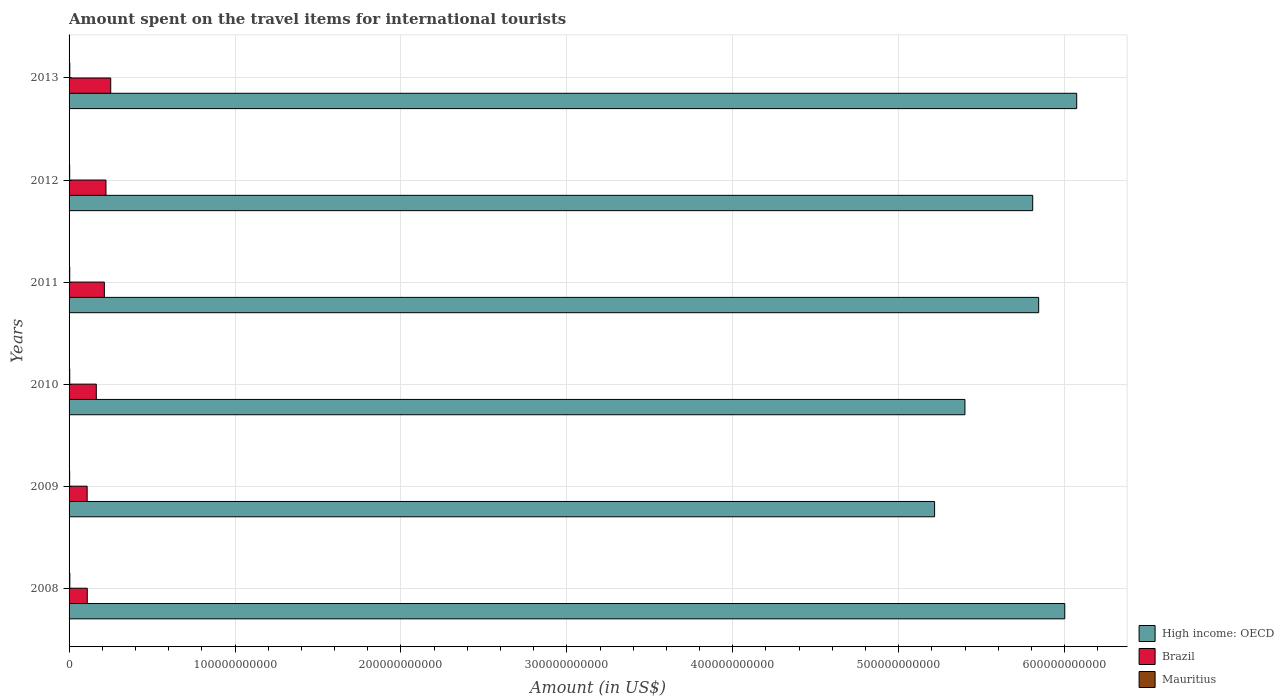How many different coloured bars are there?
Make the answer very short. 3. Are the number of bars on each tick of the Y-axis equal?
Make the answer very short. Yes. What is the amount spent on the travel items for international tourists in Brazil in 2010?
Provide a succinct answer. 1.64e+1. Across all years, what is the maximum amount spent on the travel items for international tourists in Mauritius?
Provide a short and direct response. 4.52e+08. Across all years, what is the minimum amount spent on the travel items for international tourists in High income: OECD?
Offer a terse response. 5.22e+11. What is the total amount spent on the travel items for international tourists in Mauritius in the graph?
Provide a short and direct response. 2.41e+09. What is the difference between the amount spent on the travel items for international tourists in High income: OECD in 2009 and that in 2010?
Provide a short and direct response. -1.83e+1. What is the difference between the amount spent on the travel items for international tourists in Brazil in 2009 and the amount spent on the travel items for international tourists in Mauritius in 2011?
Offer a very short reply. 1.05e+1. What is the average amount spent on the travel items for international tourists in High income: OECD per year?
Your answer should be compact. 5.72e+11. In the year 2012, what is the difference between the amount spent on the travel items for international tourists in Brazil and amount spent on the travel items for international tourists in Mauritius?
Your answer should be compact. 2.19e+1. What is the ratio of the amount spent on the travel items for international tourists in Brazil in 2012 to that in 2013?
Ensure brevity in your answer.  0.89. What is the difference between the highest and the second highest amount spent on the travel items for international tourists in Mauritius?
Your response must be concise. 1.60e+07. What is the difference between the highest and the lowest amount spent on the travel items for international tourists in Brazil?
Your answer should be very brief. 1.42e+1. In how many years, is the amount spent on the travel items for international tourists in Brazil greater than the average amount spent on the travel items for international tourists in Brazil taken over all years?
Provide a short and direct response. 3. Is the sum of the amount spent on the travel items for international tourists in High income: OECD in 2012 and 2013 greater than the maximum amount spent on the travel items for international tourists in Mauritius across all years?
Make the answer very short. Yes. What does the 3rd bar from the top in 2011 represents?
Your answer should be very brief. High income: OECD. What does the 2nd bar from the bottom in 2013 represents?
Your response must be concise. Brazil. Is it the case that in every year, the sum of the amount spent on the travel items for international tourists in High income: OECD and amount spent on the travel items for international tourists in Brazil is greater than the amount spent on the travel items for international tourists in Mauritius?
Keep it short and to the point. Yes. How many years are there in the graph?
Your answer should be compact. 6. What is the difference between two consecutive major ticks on the X-axis?
Provide a short and direct response. 1.00e+11. What is the title of the graph?
Your answer should be very brief. Amount spent on the travel items for international tourists. Does "Samoa" appear as one of the legend labels in the graph?
Provide a short and direct response. No. What is the label or title of the X-axis?
Provide a short and direct response. Amount (in US$). What is the label or title of the Y-axis?
Ensure brevity in your answer.  Years. What is the Amount (in US$) in High income: OECD in 2008?
Your response must be concise. 6.00e+11. What is the Amount (in US$) of Brazil in 2008?
Offer a very short reply. 1.10e+1. What is the Amount (in US$) of Mauritius in 2008?
Your answer should be very brief. 4.52e+08. What is the Amount (in US$) of High income: OECD in 2009?
Provide a succinct answer. 5.22e+11. What is the Amount (in US$) in Brazil in 2009?
Give a very brief answer. 1.09e+1. What is the Amount (in US$) in Mauritius in 2009?
Offer a very short reply. 3.54e+08. What is the Amount (in US$) of High income: OECD in 2010?
Ensure brevity in your answer.  5.40e+11. What is the Amount (in US$) of Brazil in 2010?
Offer a terse response. 1.64e+1. What is the Amount (in US$) of Mauritius in 2010?
Offer a very short reply. 3.98e+08. What is the Amount (in US$) of High income: OECD in 2011?
Make the answer very short. 5.84e+11. What is the Amount (in US$) of Brazil in 2011?
Your answer should be very brief. 2.13e+1. What is the Amount (in US$) of Mauritius in 2011?
Your answer should be very brief. 4.00e+08. What is the Amount (in US$) in High income: OECD in 2012?
Your answer should be compact. 5.81e+11. What is the Amount (in US$) of Brazil in 2012?
Keep it short and to the point. 2.22e+1. What is the Amount (in US$) of Mauritius in 2012?
Make the answer very short. 3.66e+08. What is the Amount (in US$) of High income: OECD in 2013?
Provide a short and direct response. 6.07e+11. What is the Amount (in US$) of Brazil in 2013?
Provide a succinct answer. 2.51e+1. What is the Amount (in US$) of Mauritius in 2013?
Offer a very short reply. 4.36e+08. Across all years, what is the maximum Amount (in US$) in High income: OECD?
Ensure brevity in your answer.  6.07e+11. Across all years, what is the maximum Amount (in US$) in Brazil?
Your answer should be very brief. 2.51e+1. Across all years, what is the maximum Amount (in US$) of Mauritius?
Provide a short and direct response. 4.52e+08. Across all years, what is the minimum Amount (in US$) of High income: OECD?
Your answer should be very brief. 5.22e+11. Across all years, what is the minimum Amount (in US$) of Brazil?
Provide a succinct answer. 1.09e+1. Across all years, what is the minimum Amount (in US$) in Mauritius?
Your answer should be very brief. 3.54e+08. What is the total Amount (in US$) in High income: OECD in the graph?
Your answer should be compact. 3.43e+12. What is the total Amount (in US$) of Brazil in the graph?
Give a very brief answer. 1.07e+11. What is the total Amount (in US$) of Mauritius in the graph?
Make the answer very short. 2.41e+09. What is the difference between the Amount (in US$) of High income: OECD in 2008 and that in 2009?
Your answer should be very brief. 7.85e+1. What is the difference between the Amount (in US$) in Brazil in 2008 and that in 2009?
Your answer should be very brief. 6.40e+07. What is the difference between the Amount (in US$) in Mauritius in 2008 and that in 2009?
Provide a short and direct response. 9.80e+07. What is the difference between the Amount (in US$) in High income: OECD in 2008 and that in 2010?
Ensure brevity in your answer.  6.02e+1. What is the difference between the Amount (in US$) in Brazil in 2008 and that in 2010?
Provide a succinct answer. -5.46e+09. What is the difference between the Amount (in US$) of Mauritius in 2008 and that in 2010?
Your response must be concise. 5.40e+07. What is the difference between the Amount (in US$) in High income: OECD in 2008 and that in 2011?
Give a very brief answer. 1.57e+1. What is the difference between the Amount (in US$) in Brazil in 2008 and that in 2011?
Give a very brief answer. -1.03e+1. What is the difference between the Amount (in US$) of Mauritius in 2008 and that in 2011?
Your answer should be compact. 5.20e+07. What is the difference between the Amount (in US$) in High income: OECD in 2008 and that in 2012?
Keep it short and to the point. 1.93e+1. What is the difference between the Amount (in US$) of Brazil in 2008 and that in 2012?
Give a very brief answer. -1.13e+1. What is the difference between the Amount (in US$) in Mauritius in 2008 and that in 2012?
Your answer should be compact. 8.60e+07. What is the difference between the Amount (in US$) in High income: OECD in 2008 and that in 2013?
Provide a short and direct response. -7.19e+09. What is the difference between the Amount (in US$) of Brazil in 2008 and that in 2013?
Offer a terse response. -1.41e+1. What is the difference between the Amount (in US$) in Mauritius in 2008 and that in 2013?
Provide a short and direct response. 1.60e+07. What is the difference between the Amount (in US$) in High income: OECD in 2009 and that in 2010?
Offer a terse response. -1.83e+1. What is the difference between the Amount (in US$) of Brazil in 2009 and that in 2010?
Offer a very short reply. -5.52e+09. What is the difference between the Amount (in US$) in Mauritius in 2009 and that in 2010?
Provide a short and direct response. -4.40e+07. What is the difference between the Amount (in US$) of High income: OECD in 2009 and that in 2011?
Ensure brevity in your answer.  -6.27e+1. What is the difference between the Amount (in US$) of Brazil in 2009 and that in 2011?
Keep it short and to the point. -1.04e+1. What is the difference between the Amount (in US$) of Mauritius in 2009 and that in 2011?
Your answer should be very brief. -4.60e+07. What is the difference between the Amount (in US$) in High income: OECD in 2009 and that in 2012?
Offer a terse response. -5.91e+1. What is the difference between the Amount (in US$) of Brazil in 2009 and that in 2012?
Keep it short and to the point. -1.13e+1. What is the difference between the Amount (in US$) of Mauritius in 2009 and that in 2012?
Your answer should be very brief. -1.20e+07. What is the difference between the Amount (in US$) of High income: OECD in 2009 and that in 2013?
Make the answer very short. -8.56e+1. What is the difference between the Amount (in US$) of Brazil in 2009 and that in 2013?
Make the answer very short. -1.42e+1. What is the difference between the Amount (in US$) of Mauritius in 2009 and that in 2013?
Keep it short and to the point. -8.20e+07. What is the difference between the Amount (in US$) in High income: OECD in 2010 and that in 2011?
Keep it short and to the point. -4.44e+1. What is the difference between the Amount (in US$) in Brazil in 2010 and that in 2011?
Ensure brevity in your answer.  -4.84e+09. What is the difference between the Amount (in US$) of Mauritius in 2010 and that in 2011?
Offer a terse response. -2.00e+06. What is the difference between the Amount (in US$) in High income: OECD in 2010 and that in 2012?
Provide a succinct answer. -4.08e+1. What is the difference between the Amount (in US$) of Brazil in 2010 and that in 2012?
Your answer should be compact. -5.81e+09. What is the difference between the Amount (in US$) of Mauritius in 2010 and that in 2012?
Make the answer very short. 3.20e+07. What is the difference between the Amount (in US$) of High income: OECD in 2010 and that in 2013?
Your answer should be compact. -6.74e+1. What is the difference between the Amount (in US$) of Brazil in 2010 and that in 2013?
Your answer should be compact. -8.68e+09. What is the difference between the Amount (in US$) of Mauritius in 2010 and that in 2013?
Offer a terse response. -3.80e+07. What is the difference between the Amount (in US$) of High income: OECD in 2011 and that in 2012?
Offer a very short reply. 3.60e+09. What is the difference between the Amount (in US$) in Brazil in 2011 and that in 2012?
Your answer should be very brief. -9.69e+08. What is the difference between the Amount (in US$) in Mauritius in 2011 and that in 2012?
Ensure brevity in your answer.  3.40e+07. What is the difference between the Amount (in US$) of High income: OECD in 2011 and that in 2013?
Offer a terse response. -2.29e+1. What is the difference between the Amount (in US$) of Brazil in 2011 and that in 2013?
Make the answer very short. -3.84e+09. What is the difference between the Amount (in US$) of Mauritius in 2011 and that in 2013?
Provide a short and direct response. -3.60e+07. What is the difference between the Amount (in US$) of High income: OECD in 2012 and that in 2013?
Your answer should be very brief. -2.65e+1. What is the difference between the Amount (in US$) in Brazil in 2012 and that in 2013?
Provide a short and direct response. -2.87e+09. What is the difference between the Amount (in US$) of Mauritius in 2012 and that in 2013?
Offer a terse response. -7.00e+07. What is the difference between the Amount (in US$) in High income: OECD in 2008 and the Amount (in US$) in Brazil in 2009?
Provide a short and direct response. 5.89e+11. What is the difference between the Amount (in US$) of High income: OECD in 2008 and the Amount (in US$) of Mauritius in 2009?
Provide a succinct answer. 6.00e+11. What is the difference between the Amount (in US$) in Brazil in 2008 and the Amount (in US$) in Mauritius in 2009?
Provide a short and direct response. 1.06e+1. What is the difference between the Amount (in US$) of High income: OECD in 2008 and the Amount (in US$) of Brazil in 2010?
Offer a very short reply. 5.84e+11. What is the difference between the Amount (in US$) in High income: OECD in 2008 and the Amount (in US$) in Mauritius in 2010?
Provide a short and direct response. 6.00e+11. What is the difference between the Amount (in US$) of Brazil in 2008 and the Amount (in US$) of Mauritius in 2010?
Your response must be concise. 1.06e+1. What is the difference between the Amount (in US$) in High income: OECD in 2008 and the Amount (in US$) in Brazil in 2011?
Provide a succinct answer. 5.79e+11. What is the difference between the Amount (in US$) in High income: OECD in 2008 and the Amount (in US$) in Mauritius in 2011?
Your answer should be compact. 6.00e+11. What is the difference between the Amount (in US$) of Brazil in 2008 and the Amount (in US$) of Mauritius in 2011?
Make the answer very short. 1.06e+1. What is the difference between the Amount (in US$) of High income: OECD in 2008 and the Amount (in US$) of Brazil in 2012?
Your answer should be very brief. 5.78e+11. What is the difference between the Amount (in US$) in High income: OECD in 2008 and the Amount (in US$) in Mauritius in 2012?
Offer a very short reply. 6.00e+11. What is the difference between the Amount (in US$) in Brazil in 2008 and the Amount (in US$) in Mauritius in 2012?
Provide a short and direct response. 1.06e+1. What is the difference between the Amount (in US$) in High income: OECD in 2008 and the Amount (in US$) in Brazil in 2013?
Keep it short and to the point. 5.75e+11. What is the difference between the Amount (in US$) of High income: OECD in 2008 and the Amount (in US$) of Mauritius in 2013?
Ensure brevity in your answer.  6.00e+11. What is the difference between the Amount (in US$) of Brazil in 2008 and the Amount (in US$) of Mauritius in 2013?
Your response must be concise. 1.05e+1. What is the difference between the Amount (in US$) in High income: OECD in 2009 and the Amount (in US$) in Brazil in 2010?
Ensure brevity in your answer.  5.05e+11. What is the difference between the Amount (in US$) in High income: OECD in 2009 and the Amount (in US$) in Mauritius in 2010?
Your response must be concise. 5.21e+11. What is the difference between the Amount (in US$) in Brazil in 2009 and the Amount (in US$) in Mauritius in 2010?
Provide a succinct answer. 1.05e+1. What is the difference between the Amount (in US$) of High income: OECD in 2009 and the Amount (in US$) of Brazil in 2011?
Offer a very short reply. 5.00e+11. What is the difference between the Amount (in US$) of High income: OECD in 2009 and the Amount (in US$) of Mauritius in 2011?
Offer a terse response. 5.21e+11. What is the difference between the Amount (in US$) of Brazil in 2009 and the Amount (in US$) of Mauritius in 2011?
Offer a terse response. 1.05e+1. What is the difference between the Amount (in US$) of High income: OECD in 2009 and the Amount (in US$) of Brazil in 2012?
Your answer should be compact. 4.99e+11. What is the difference between the Amount (in US$) of High income: OECD in 2009 and the Amount (in US$) of Mauritius in 2012?
Give a very brief answer. 5.21e+11. What is the difference between the Amount (in US$) of Brazil in 2009 and the Amount (in US$) of Mauritius in 2012?
Provide a succinct answer. 1.05e+1. What is the difference between the Amount (in US$) of High income: OECD in 2009 and the Amount (in US$) of Brazil in 2013?
Provide a short and direct response. 4.97e+11. What is the difference between the Amount (in US$) in High income: OECD in 2009 and the Amount (in US$) in Mauritius in 2013?
Provide a short and direct response. 5.21e+11. What is the difference between the Amount (in US$) of Brazil in 2009 and the Amount (in US$) of Mauritius in 2013?
Offer a terse response. 1.05e+1. What is the difference between the Amount (in US$) in High income: OECD in 2010 and the Amount (in US$) in Brazil in 2011?
Provide a short and direct response. 5.19e+11. What is the difference between the Amount (in US$) in High income: OECD in 2010 and the Amount (in US$) in Mauritius in 2011?
Offer a very short reply. 5.40e+11. What is the difference between the Amount (in US$) of Brazil in 2010 and the Amount (in US$) of Mauritius in 2011?
Provide a short and direct response. 1.60e+1. What is the difference between the Amount (in US$) of High income: OECD in 2010 and the Amount (in US$) of Brazil in 2012?
Make the answer very short. 5.18e+11. What is the difference between the Amount (in US$) in High income: OECD in 2010 and the Amount (in US$) in Mauritius in 2012?
Your response must be concise. 5.40e+11. What is the difference between the Amount (in US$) of Brazil in 2010 and the Amount (in US$) of Mauritius in 2012?
Keep it short and to the point. 1.61e+1. What is the difference between the Amount (in US$) of High income: OECD in 2010 and the Amount (in US$) of Brazil in 2013?
Your answer should be compact. 5.15e+11. What is the difference between the Amount (in US$) of High income: OECD in 2010 and the Amount (in US$) of Mauritius in 2013?
Your answer should be very brief. 5.39e+11. What is the difference between the Amount (in US$) in Brazil in 2010 and the Amount (in US$) in Mauritius in 2013?
Give a very brief answer. 1.60e+1. What is the difference between the Amount (in US$) of High income: OECD in 2011 and the Amount (in US$) of Brazil in 2012?
Ensure brevity in your answer.  5.62e+11. What is the difference between the Amount (in US$) of High income: OECD in 2011 and the Amount (in US$) of Mauritius in 2012?
Ensure brevity in your answer.  5.84e+11. What is the difference between the Amount (in US$) in Brazil in 2011 and the Amount (in US$) in Mauritius in 2012?
Your answer should be compact. 2.09e+1. What is the difference between the Amount (in US$) of High income: OECD in 2011 and the Amount (in US$) of Brazil in 2013?
Your answer should be compact. 5.59e+11. What is the difference between the Amount (in US$) of High income: OECD in 2011 and the Amount (in US$) of Mauritius in 2013?
Your answer should be very brief. 5.84e+11. What is the difference between the Amount (in US$) of Brazil in 2011 and the Amount (in US$) of Mauritius in 2013?
Your response must be concise. 2.08e+1. What is the difference between the Amount (in US$) in High income: OECD in 2012 and the Amount (in US$) in Brazil in 2013?
Your response must be concise. 5.56e+11. What is the difference between the Amount (in US$) in High income: OECD in 2012 and the Amount (in US$) in Mauritius in 2013?
Make the answer very short. 5.80e+11. What is the difference between the Amount (in US$) of Brazil in 2012 and the Amount (in US$) of Mauritius in 2013?
Keep it short and to the point. 2.18e+1. What is the average Amount (in US$) of High income: OECD per year?
Offer a terse response. 5.72e+11. What is the average Amount (in US$) in Brazil per year?
Offer a terse response. 1.78e+1. What is the average Amount (in US$) in Mauritius per year?
Provide a short and direct response. 4.01e+08. In the year 2008, what is the difference between the Amount (in US$) of High income: OECD and Amount (in US$) of Brazil?
Ensure brevity in your answer.  5.89e+11. In the year 2008, what is the difference between the Amount (in US$) in High income: OECD and Amount (in US$) in Mauritius?
Your answer should be compact. 6.00e+11. In the year 2008, what is the difference between the Amount (in US$) of Brazil and Amount (in US$) of Mauritius?
Keep it short and to the point. 1.05e+1. In the year 2009, what is the difference between the Amount (in US$) of High income: OECD and Amount (in US$) of Brazil?
Ensure brevity in your answer.  5.11e+11. In the year 2009, what is the difference between the Amount (in US$) of High income: OECD and Amount (in US$) of Mauritius?
Give a very brief answer. 5.21e+11. In the year 2009, what is the difference between the Amount (in US$) of Brazil and Amount (in US$) of Mauritius?
Keep it short and to the point. 1.05e+1. In the year 2010, what is the difference between the Amount (in US$) of High income: OECD and Amount (in US$) of Brazil?
Your answer should be very brief. 5.24e+11. In the year 2010, what is the difference between the Amount (in US$) in High income: OECD and Amount (in US$) in Mauritius?
Your response must be concise. 5.40e+11. In the year 2010, what is the difference between the Amount (in US$) in Brazil and Amount (in US$) in Mauritius?
Your answer should be compact. 1.60e+1. In the year 2011, what is the difference between the Amount (in US$) of High income: OECD and Amount (in US$) of Brazil?
Provide a succinct answer. 5.63e+11. In the year 2011, what is the difference between the Amount (in US$) in High income: OECD and Amount (in US$) in Mauritius?
Give a very brief answer. 5.84e+11. In the year 2011, what is the difference between the Amount (in US$) in Brazil and Amount (in US$) in Mauritius?
Ensure brevity in your answer.  2.09e+1. In the year 2012, what is the difference between the Amount (in US$) in High income: OECD and Amount (in US$) in Brazil?
Give a very brief answer. 5.59e+11. In the year 2012, what is the difference between the Amount (in US$) in High income: OECD and Amount (in US$) in Mauritius?
Provide a short and direct response. 5.80e+11. In the year 2012, what is the difference between the Amount (in US$) in Brazil and Amount (in US$) in Mauritius?
Your answer should be very brief. 2.19e+1. In the year 2013, what is the difference between the Amount (in US$) in High income: OECD and Amount (in US$) in Brazil?
Make the answer very short. 5.82e+11. In the year 2013, what is the difference between the Amount (in US$) in High income: OECD and Amount (in US$) in Mauritius?
Ensure brevity in your answer.  6.07e+11. In the year 2013, what is the difference between the Amount (in US$) in Brazil and Amount (in US$) in Mauritius?
Offer a terse response. 2.47e+1. What is the ratio of the Amount (in US$) in High income: OECD in 2008 to that in 2009?
Your answer should be compact. 1.15. What is the ratio of the Amount (in US$) in Brazil in 2008 to that in 2009?
Your answer should be very brief. 1.01. What is the ratio of the Amount (in US$) of Mauritius in 2008 to that in 2009?
Offer a terse response. 1.28. What is the ratio of the Amount (in US$) in High income: OECD in 2008 to that in 2010?
Provide a short and direct response. 1.11. What is the ratio of the Amount (in US$) of Brazil in 2008 to that in 2010?
Offer a very short reply. 0.67. What is the ratio of the Amount (in US$) in Mauritius in 2008 to that in 2010?
Give a very brief answer. 1.14. What is the ratio of the Amount (in US$) in High income: OECD in 2008 to that in 2011?
Give a very brief answer. 1.03. What is the ratio of the Amount (in US$) in Brazil in 2008 to that in 2011?
Give a very brief answer. 0.52. What is the ratio of the Amount (in US$) in Mauritius in 2008 to that in 2011?
Offer a very short reply. 1.13. What is the ratio of the Amount (in US$) of High income: OECD in 2008 to that in 2012?
Keep it short and to the point. 1.03. What is the ratio of the Amount (in US$) in Brazil in 2008 to that in 2012?
Provide a short and direct response. 0.49. What is the ratio of the Amount (in US$) of Mauritius in 2008 to that in 2012?
Give a very brief answer. 1.24. What is the ratio of the Amount (in US$) of Brazil in 2008 to that in 2013?
Give a very brief answer. 0.44. What is the ratio of the Amount (in US$) of Mauritius in 2008 to that in 2013?
Make the answer very short. 1.04. What is the ratio of the Amount (in US$) of High income: OECD in 2009 to that in 2010?
Your response must be concise. 0.97. What is the ratio of the Amount (in US$) of Brazil in 2009 to that in 2010?
Offer a very short reply. 0.66. What is the ratio of the Amount (in US$) in Mauritius in 2009 to that in 2010?
Offer a very short reply. 0.89. What is the ratio of the Amount (in US$) in High income: OECD in 2009 to that in 2011?
Offer a very short reply. 0.89. What is the ratio of the Amount (in US$) of Brazil in 2009 to that in 2011?
Ensure brevity in your answer.  0.51. What is the ratio of the Amount (in US$) in Mauritius in 2009 to that in 2011?
Ensure brevity in your answer.  0.89. What is the ratio of the Amount (in US$) in High income: OECD in 2009 to that in 2012?
Provide a succinct answer. 0.9. What is the ratio of the Amount (in US$) in Brazil in 2009 to that in 2012?
Ensure brevity in your answer.  0.49. What is the ratio of the Amount (in US$) of Mauritius in 2009 to that in 2012?
Ensure brevity in your answer.  0.97. What is the ratio of the Amount (in US$) of High income: OECD in 2009 to that in 2013?
Your response must be concise. 0.86. What is the ratio of the Amount (in US$) of Brazil in 2009 to that in 2013?
Make the answer very short. 0.43. What is the ratio of the Amount (in US$) in Mauritius in 2009 to that in 2013?
Your response must be concise. 0.81. What is the ratio of the Amount (in US$) in High income: OECD in 2010 to that in 2011?
Your answer should be compact. 0.92. What is the ratio of the Amount (in US$) of Brazil in 2010 to that in 2011?
Your response must be concise. 0.77. What is the ratio of the Amount (in US$) of High income: OECD in 2010 to that in 2012?
Keep it short and to the point. 0.93. What is the ratio of the Amount (in US$) of Brazil in 2010 to that in 2012?
Your response must be concise. 0.74. What is the ratio of the Amount (in US$) in Mauritius in 2010 to that in 2012?
Ensure brevity in your answer.  1.09. What is the ratio of the Amount (in US$) in High income: OECD in 2010 to that in 2013?
Your answer should be compact. 0.89. What is the ratio of the Amount (in US$) of Brazil in 2010 to that in 2013?
Keep it short and to the point. 0.65. What is the ratio of the Amount (in US$) in Mauritius in 2010 to that in 2013?
Make the answer very short. 0.91. What is the ratio of the Amount (in US$) in Brazil in 2011 to that in 2012?
Offer a very short reply. 0.96. What is the ratio of the Amount (in US$) of Mauritius in 2011 to that in 2012?
Your answer should be compact. 1.09. What is the ratio of the Amount (in US$) in High income: OECD in 2011 to that in 2013?
Provide a short and direct response. 0.96. What is the ratio of the Amount (in US$) of Brazil in 2011 to that in 2013?
Provide a short and direct response. 0.85. What is the ratio of the Amount (in US$) of Mauritius in 2011 to that in 2013?
Offer a terse response. 0.92. What is the ratio of the Amount (in US$) in High income: OECD in 2012 to that in 2013?
Make the answer very short. 0.96. What is the ratio of the Amount (in US$) in Brazil in 2012 to that in 2013?
Keep it short and to the point. 0.89. What is the ratio of the Amount (in US$) of Mauritius in 2012 to that in 2013?
Make the answer very short. 0.84. What is the difference between the highest and the second highest Amount (in US$) in High income: OECD?
Provide a short and direct response. 7.19e+09. What is the difference between the highest and the second highest Amount (in US$) of Brazil?
Your response must be concise. 2.87e+09. What is the difference between the highest and the second highest Amount (in US$) in Mauritius?
Your answer should be compact. 1.60e+07. What is the difference between the highest and the lowest Amount (in US$) in High income: OECD?
Offer a terse response. 8.56e+1. What is the difference between the highest and the lowest Amount (in US$) in Brazil?
Keep it short and to the point. 1.42e+1. What is the difference between the highest and the lowest Amount (in US$) in Mauritius?
Keep it short and to the point. 9.80e+07. 